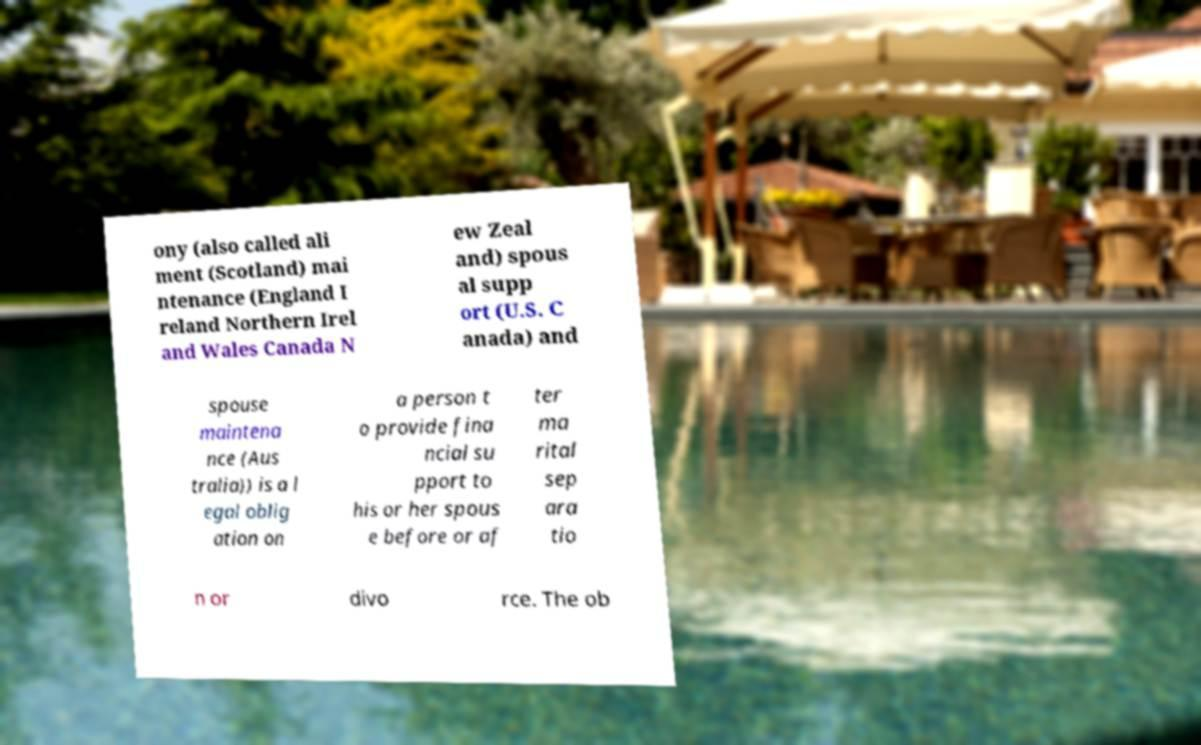Please identify and transcribe the text found in this image. ony (also called ali ment (Scotland) mai ntenance (England I reland Northern Irel and Wales Canada N ew Zeal and) spous al supp ort (U.S. C anada) and spouse maintena nce (Aus tralia)) is a l egal oblig ation on a person t o provide fina ncial su pport to his or her spous e before or af ter ma rital sep ara tio n or divo rce. The ob 